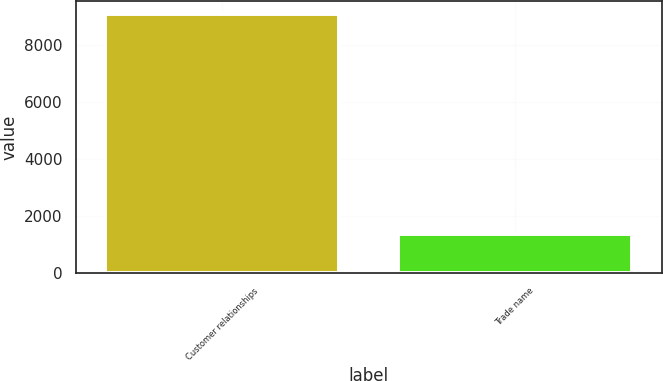Convert chart. <chart><loc_0><loc_0><loc_500><loc_500><bar_chart><fcel>Customer relationships<fcel>Trade name<nl><fcel>9098<fcel>1384<nl></chart> 